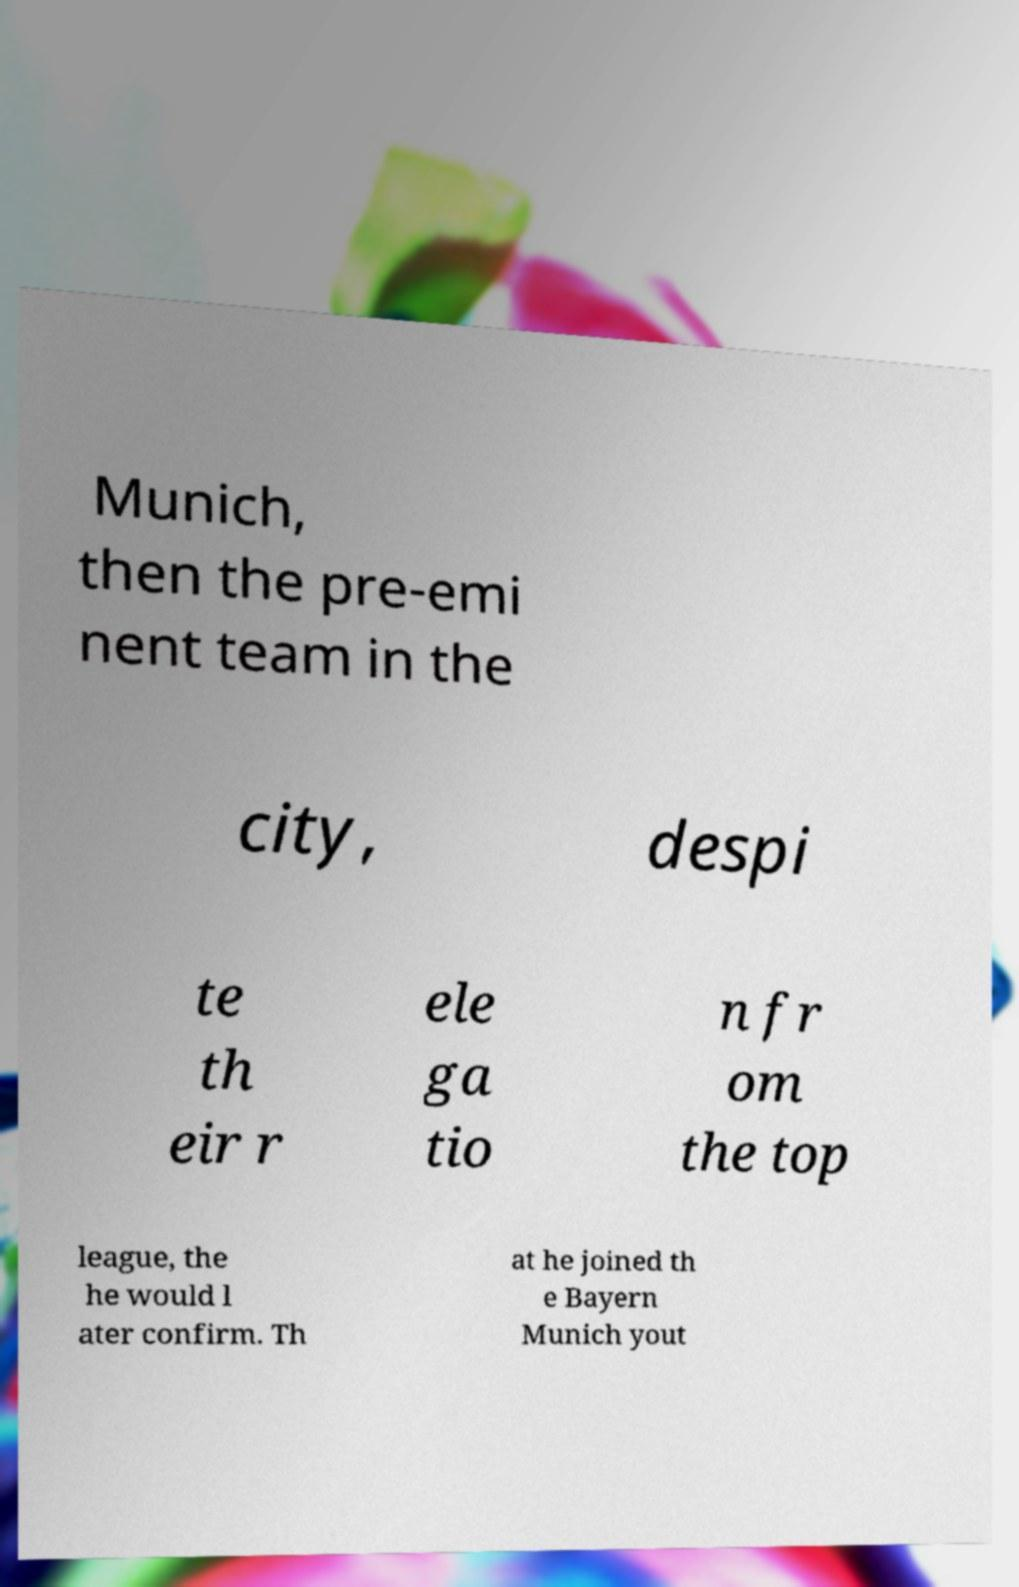Please identify and transcribe the text found in this image. Munich, then the pre-emi nent team in the city, despi te th eir r ele ga tio n fr om the top league, the he would l ater confirm. Th at he joined th e Bayern Munich yout 